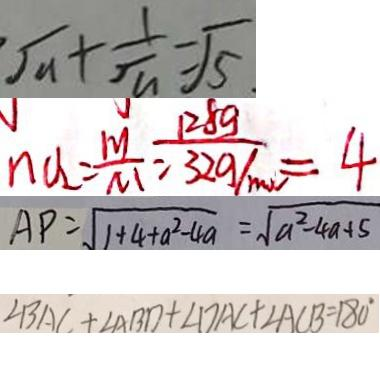<formula> <loc_0><loc_0><loc_500><loc_500>\sqrt { a } + \frac { 1 } { \sqrt { a } } = \sqrt { 5 } 
 n V _ { 2 } = \frac { m } { M } = \frac { 1 2 8 g } { 3 2 g / m o l } = 4 
 A P = \sqrt { 1 + 4 + a ^ { 2 } - 4 a } = \sqrt { a ^ { 2 } - 4 a + 5 } 
 \angle B A C + \angle A B D + \angle D A C + \angle A C B = 1 8 0 ^ { \circ }</formula> 